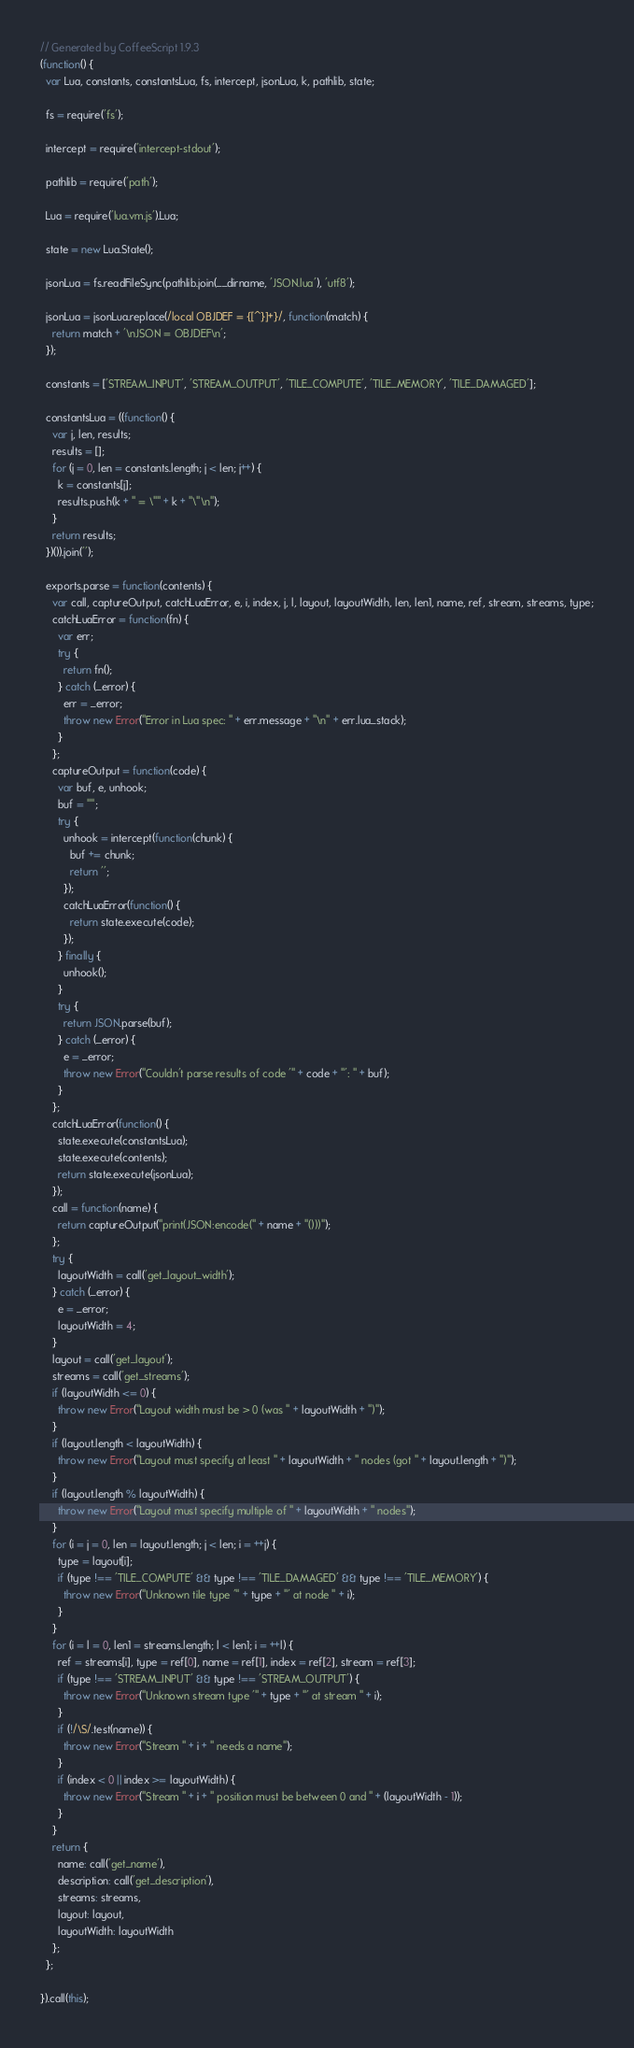<code> <loc_0><loc_0><loc_500><loc_500><_JavaScript_>// Generated by CoffeeScript 1.9.3
(function() {
  var Lua, constants, constantsLua, fs, intercept, jsonLua, k, pathlib, state;

  fs = require('fs');

  intercept = require('intercept-stdout');

  pathlib = require('path');

  Lua = require('lua.vm.js').Lua;

  state = new Lua.State();

  jsonLua = fs.readFileSync(pathlib.join(__dirname, 'JSON.lua'), 'utf8');

  jsonLua = jsonLua.replace(/local OBJDEF = {[^}]+}/, function(match) {
    return match + '\nJSON = OBJDEF\n';
  });

  constants = ['STREAM_INPUT', 'STREAM_OUTPUT', 'TILE_COMPUTE', 'TILE_MEMORY', 'TILE_DAMAGED'];

  constantsLua = ((function() {
    var j, len, results;
    results = [];
    for (j = 0, len = constants.length; j < len; j++) {
      k = constants[j];
      results.push(k + " = \"" + k + "\"\n");
    }
    return results;
  })()).join('');

  exports.parse = function(contents) {
    var call, captureOutput, catchLuaError, e, i, index, j, l, layout, layoutWidth, len, len1, name, ref, stream, streams, type;
    catchLuaError = function(fn) {
      var err;
      try {
        return fn();
      } catch (_error) {
        err = _error;
        throw new Error("Error in Lua spec: " + err.message + "\n" + err.lua_stack);
      }
    };
    captureOutput = function(code) {
      var buf, e, unhook;
      buf = "";
      try {
        unhook = intercept(function(chunk) {
          buf += chunk;
          return '';
        });
        catchLuaError(function() {
          return state.execute(code);
        });
      } finally {
        unhook();
      }
      try {
        return JSON.parse(buf);
      } catch (_error) {
        e = _error;
        throw new Error("Couldn't parse results of code '" + code + "': " + buf);
      }
    };
    catchLuaError(function() {
      state.execute(constantsLua);
      state.execute(contents);
      return state.execute(jsonLua);
    });
    call = function(name) {
      return captureOutput("print(JSON:encode(" + name + "()))");
    };
    try {
      layoutWidth = call('get_layout_width');
    } catch (_error) {
      e = _error;
      layoutWidth = 4;
    }
    layout = call('get_layout');
    streams = call('get_streams');
    if (layoutWidth <= 0) {
      throw new Error("Layout width must be > 0 (was " + layoutWidth + ")");
    }
    if (layout.length < layoutWidth) {
      throw new Error("Layout must specify at least " + layoutWidth + " nodes (got " + layout.length + ")");
    }
    if (layout.length % layoutWidth) {
      throw new Error("Layout must specify multiple of " + layoutWidth + " nodes");
    }
    for (i = j = 0, len = layout.length; j < len; i = ++j) {
      type = layout[i];
      if (type !== 'TILE_COMPUTE' && type !== 'TILE_DAMAGED' && type !== 'TILE_MEMORY') {
        throw new Error("Unknown tile type '" + type + "' at node " + i);
      }
    }
    for (i = l = 0, len1 = streams.length; l < len1; i = ++l) {
      ref = streams[i], type = ref[0], name = ref[1], index = ref[2], stream = ref[3];
      if (type !== 'STREAM_INPUT' && type !== 'STREAM_OUTPUT') {
        throw new Error("Unknown stream type '" + type + "' at stream " + i);
      }
      if (!/\S/.test(name)) {
        throw new Error("Stream " + i + " needs a name");
      }
      if (index < 0 || index >= layoutWidth) {
        throw new Error("Stream " + i + " position must be between 0 and " + (layoutWidth - 1));
      }
    }
    return {
      name: call('get_name'),
      description: call('get_description'),
      streams: streams,
      layout: layout,
      layoutWidth: layoutWidth
    };
  };

}).call(this);
</code> 